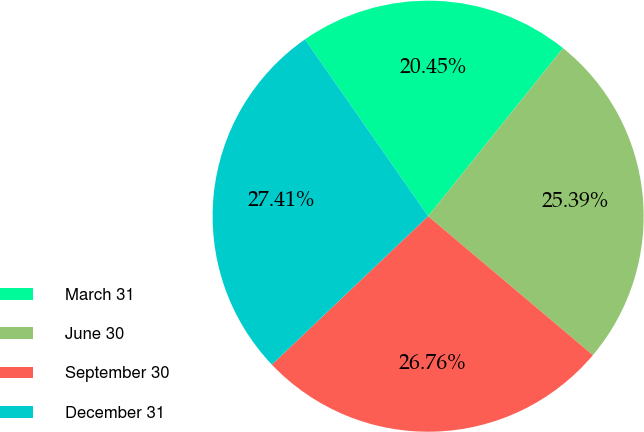<chart> <loc_0><loc_0><loc_500><loc_500><pie_chart><fcel>March 31<fcel>June 30<fcel>September 30<fcel>December 31<nl><fcel>20.45%<fcel>25.39%<fcel>26.76%<fcel>27.41%<nl></chart> 